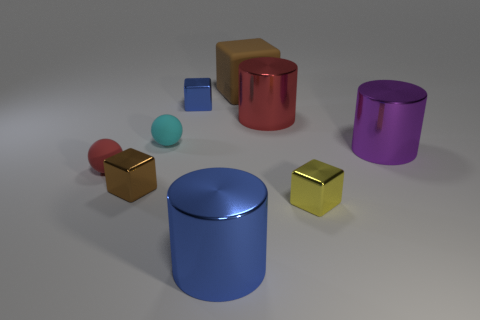Do the red metallic object and the cylinder to the left of the big matte object have the same size?
Make the answer very short. Yes. What number of things are metallic objects in front of the big purple shiny thing or cubes behind the tiny blue block?
Your answer should be very brief. 4. There is a blue thing that is the same size as the matte cube; what shape is it?
Make the answer very short. Cylinder. There is a large object to the right of the metal cube in front of the brown block to the left of the cyan matte sphere; what shape is it?
Ensure brevity in your answer.  Cylinder. Are there an equal number of yellow objects behind the small red matte ball and blue cubes?
Your answer should be compact. No. Does the red cylinder have the same size as the red rubber sphere?
Your answer should be very brief. No. What number of rubber things are either big brown cubes or small gray things?
Offer a terse response. 1. There is a yellow block that is the same size as the brown shiny object; what is it made of?
Give a very brief answer. Metal. How many other things are there of the same material as the large brown object?
Make the answer very short. 2. Is the number of tiny objects that are left of the tiny red ball less than the number of large red rubber blocks?
Provide a succinct answer. No. 